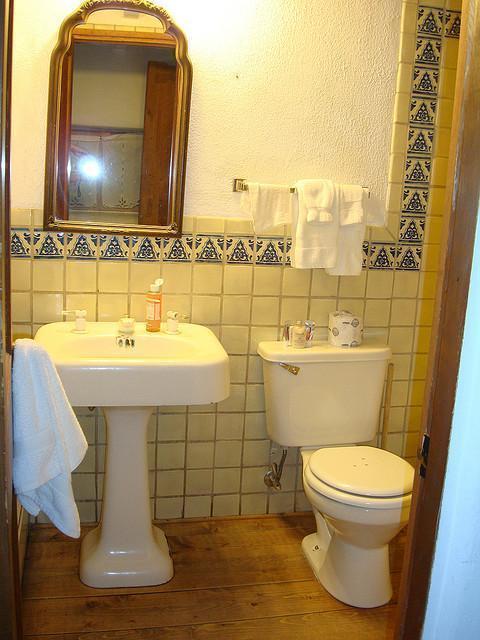Why do sanitary items comes in white color?
Answer the question by selecting the correct answer among the 4 following choices and explain your choice with a short sentence. The answer should be formatted with the following format: `Answer: choice
Rationale: rationale.`
Options: Cleanliness, none, code, protection. Answer: cleanliness.
Rationale: They look clean when they are white and are easy to see the blemishes on them. 